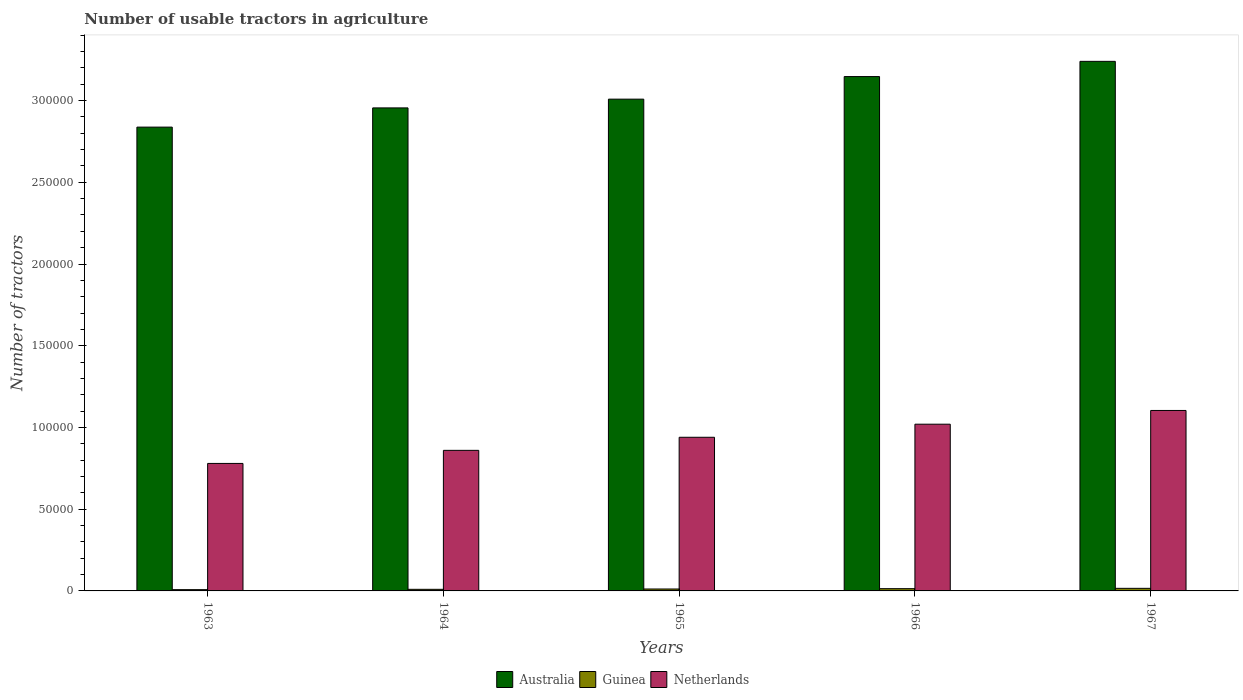How many different coloured bars are there?
Keep it short and to the point. 3. Are the number of bars per tick equal to the number of legend labels?
Make the answer very short. Yes. Are the number of bars on each tick of the X-axis equal?
Provide a short and direct response. Yes. How many bars are there on the 2nd tick from the right?
Give a very brief answer. 3. What is the label of the 3rd group of bars from the left?
Your answer should be very brief. 1965. What is the number of usable tractors in agriculture in Guinea in 1965?
Provide a succinct answer. 1180. Across all years, what is the maximum number of usable tractors in agriculture in Guinea?
Provide a short and direct response. 1579. Across all years, what is the minimum number of usable tractors in agriculture in Netherlands?
Your answer should be very brief. 7.80e+04. In which year was the number of usable tractors in agriculture in Australia maximum?
Your answer should be compact. 1967. In which year was the number of usable tractors in agriculture in Australia minimum?
Your answer should be very brief. 1963. What is the total number of usable tractors in agriculture in Guinea in the graph?
Offer a very short reply. 5898. What is the difference between the number of usable tractors in agriculture in Guinea in 1964 and that in 1967?
Your answer should be compact. -599. What is the difference between the number of usable tractors in agriculture in Australia in 1965 and the number of usable tractors in agriculture in Netherlands in 1963?
Offer a very short reply. 2.23e+05. What is the average number of usable tractors in agriculture in Guinea per year?
Ensure brevity in your answer.  1179.6. In the year 1965, what is the difference between the number of usable tractors in agriculture in Netherlands and number of usable tractors in agriculture in Australia?
Provide a succinct answer. -2.07e+05. In how many years, is the number of usable tractors in agriculture in Australia greater than 310000?
Ensure brevity in your answer.  2. What is the ratio of the number of usable tractors in agriculture in Guinea in 1964 to that in 1967?
Ensure brevity in your answer.  0.62. Is the difference between the number of usable tractors in agriculture in Netherlands in 1965 and 1967 greater than the difference between the number of usable tractors in agriculture in Australia in 1965 and 1967?
Make the answer very short. Yes. What is the difference between the highest and the second highest number of usable tractors in agriculture in Netherlands?
Your answer should be compact. 8400. What is the difference between the highest and the lowest number of usable tractors in agriculture in Australia?
Your answer should be very brief. 4.02e+04. Is the sum of the number of usable tractors in agriculture in Netherlands in 1966 and 1967 greater than the maximum number of usable tractors in agriculture in Guinea across all years?
Your answer should be very brief. Yes. What does the 2nd bar from the right in 1966 represents?
Your response must be concise. Guinea. Are all the bars in the graph horizontal?
Offer a terse response. No. How many years are there in the graph?
Ensure brevity in your answer.  5. What is the difference between two consecutive major ticks on the Y-axis?
Your answer should be very brief. 5.00e+04. Are the values on the major ticks of Y-axis written in scientific E-notation?
Keep it short and to the point. No. How many legend labels are there?
Keep it short and to the point. 3. How are the legend labels stacked?
Ensure brevity in your answer.  Horizontal. What is the title of the graph?
Your answer should be very brief. Number of usable tractors in agriculture. Does "Portugal" appear as one of the legend labels in the graph?
Make the answer very short. No. What is the label or title of the X-axis?
Keep it short and to the point. Years. What is the label or title of the Y-axis?
Your answer should be compact. Number of tractors. What is the Number of tractors in Australia in 1963?
Provide a short and direct response. 2.84e+05. What is the Number of tractors in Guinea in 1963?
Provide a short and direct response. 780. What is the Number of tractors in Netherlands in 1963?
Ensure brevity in your answer.  7.80e+04. What is the Number of tractors of Australia in 1964?
Your response must be concise. 2.96e+05. What is the Number of tractors of Guinea in 1964?
Your answer should be compact. 980. What is the Number of tractors of Netherlands in 1964?
Make the answer very short. 8.60e+04. What is the Number of tractors in Australia in 1965?
Keep it short and to the point. 3.01e+05. What is the Number of tractors of Guinea in 1965?
Offer a terse response. 1180. What is the Number of tractors of Netherlands in 1965?
Your answer should be compact. 9.40e+04. What is the Number of tractors in Australia in 1966?
Provide a succinct answer. 3.15e+05. What is the Number of tractors of Guinea in 1966?
Give a very brief answer. 1379. What is the Number of tractors in Netherlands in 1966?
Your answer should be compact. 1.02e+05. What is the Number of tractors in Australia in 1967?
Your answer should be compact. 3.24e+05. What is the Number of tractors of Guinea in 1967?
Give a very brief answer. 1579. What is the Number of tractors of Netherlands in 1967?
Offer a terse response. 1.10e+05. Across all years, what is the maximum Number of tractors in Australia?
Your answer should be compact. 3.24e+05. Across all years, what is the maximum Number of tractors in Guinea?
Provide a succinct answer. 1579. Across all years, what is the maximum Number of tractors of Netherlands?
Give a very brief answer. 1.10e+05. Across all years, what is the minimum Number of tractors of Australia?
Offer a terse response. 2.84e+05. Across all years, what is the minimum Number of tractors in Guinea?
Offer a terse response. 780. Across all years, what is the minimum Number of tractors of Netherlands?
Provide a succinct answer. 7.80e+04. What is the total Number of tractors in Australia in the graph?
Offer a terse response. 1.52e+06. What is the total Number of tractors in Guinea in the graph?
Give a very brief answer. 5898. What is the total Number of tractors in Netherlands in the graph?
Your answer should be compact. 4.70e+05. What is the difference between the Number of tractors in Australia in 1963 and that in 1964?
Keep it short and to the point. -1.18e+04. What is the difference between the Number of tractors of Guinea in 1963 and that in 1964?
Provide a short and direct response. -200. What is the difference between the Number of tractors of Netherlands in 1963 and that in 1964?
Provide a succinct answer. -8000. What is the difference between the Number of tractors of Australia in 1963 and that in 1965?
Make the answer very short. -1.71e+04. What is the difference between the Number of tractors of Guinea in 1963 and that in 1965?
Your answer should be compact. -400. What is the difference between the Number of tractors in Netherlands in 1963 and that in 1965?
Ensure brevity in your answer.  -1.60e+04. What is the difference between the Number of tractors of Australia in 1963 and that in 1966?
Offer a terse response. -3.09e+04. What is the difference between the Number of tractors of Guinea in 1963 and that in 1966?
Your response must be concise. -599. What is the difference between the Number of tractors in Netherlands in 1963 and that in 1966?
Offer a terse response. -2.40e+04. What is the difference between the Number of tractors in Australia in 1963 and that in 1967?
Provide a short and direct response. -4.02e+04. What is the difference between the Number of tractors in Guinea in 1963 and that in 1967?
Offer a terse response. -799. What is the difference between the Number of tractors of Netherlands in 1963 and that in 1967?
Provide a short and direct response. -3.24e+04. What is the difference between the Number of tractors in Australia in 1964 and that in 1965?
Make the answer very short. -5357. What is the difference between the Number of tractors of Guinea in 1964 and that in 1965?
Give a very brief answer. -200. What is the difference between the Number of tractors in Netherlands in 1964 and that in 1965?
Make the answer very short. -8000. What is the difference between the Number of tractors in Australia in 1964 and that in 1966?
Your answer should be very brief. -1.92e+04. What is the difference between the Number of tractors of Guinea in 1964 and that in 1966?
Ensure brevity in your answer.  -399. What is the difference between the Number of tractors in Netherlands in 1964 and that in 1966?
Offer a terse response. -1.60e+04. What is the difference between the Number of tractors of Australia in 1964 and that in 1967?
Offer a very short reply. -2.85e+04. What is the difference between the Number of tractors in Guinea in 1964 and that in 1967?
Provide a short and direct response. -599. What is the difference between the Number of tractors in Netherlands in 1964 and that in 1967?
Your answer should be very brief. -2.44e+04. What is the difference between the Number of tractors of Australia in 1965 and that in 1966?
Keep it short and to the point. -1.38e+04. What is the difference between the Number of tractors of Guinea in 1965 and that in 1966?
Offer a very short reply. -199. What is the difference between the Number of tractors in Netherlands in 1965 and that in 1966?
Make the answer very short. -8000. What is the difference between the Number of tractors in Australia in 1965 and that in 1967?
Provide a succinct answer. -2.31e+04. What is the difference between the Number of tractors of Guinea in 1965 and that in 1967?
Give a very brief answer. -399. What is the difference between the Number of tractors of Netherlands in 1965 and that in 1967?
Your answer should be compact. -1.64e+04. What is the difference between the Number of tractors in Australia in 1966 and that in 1967?
Your response must be concise. -9312. What is the difference between the Number of tractors of Guinea in 1966 and that in 1967?
Ensure brevity in your answer.  -200. What is the difference between the Number of tractors of Netherlands in 1966 and that in 1967?
Your answer should be compact. -8400. What is the difference between the Number of tractors of Australia in 1963 and the Number of tractors of Guinea in 1964?
Your response must be concise. 2.83e+05. What is the difference between the Number of tractors in Australia in 1963 and the Number of tractors in Netherlands in 1964?
Keep it short and to the point. 1.98e+05. What is the difference between the Number of tractors of Guinea in 1963 and the Number of tractors of Netherlands in 1964?
Provide a short and direct response. -8.52e+04. What is the difference between the Number of tractors in Australia in 1963 and the Number of tractors in Guinea in 1965?
Offer a terse response. 2.83e+05. What is the difference between the Number of tractors in Australia in 1963 and the Number of tractors in Netherlands in 1965?
Your answer should be very brief. 1.90e+05. What is the difference between the Number of tractors of Guinea in 1963 and the Number of tractors of Netherlands in 1965?
Offer a very short reply. -9.32e+04. What is the difference between the Number of tractors in Australia in 1963 and the Number of tractors in Guinea in 1966?
Your answer should be very brief. 2.82e+05. What is the difference between the Number of tractors of Australia in 1963 and the Number of tractors of Netherlands in 1966?
Make the answer very short. 1.82e+05. What is the difference between the Number of tractors in Guinea in 1963 and the Number of tractors in Netherlands in 1966?
Ensure brevity in your answer.  -1.01e+05. What is the difference between the Number of tractors of Australia in 1963 and the Number of tractors of Guinea in 1967?
Provide a short and direct response. 2.82e+05. What is the difference between the Number of tractors in Australia in 1963 and the Number of tractors in Netherlands in 1967?
Ensure brevity in your answer.  1.73e+05. What is the difference between the Number of tractors of Guinea in 1963 and the Number of tractors of Netherlands in 1967?
Offer a terse response. -1.10e+05. What is the difference between the Number of tractors in Australia in 1964 and the Number of tractors in Guinea in 1965?
Make the answer very short. 2.94e+05. What is the difference between the Number of tractors of Australia in 1964 and the Number of tractors of Netherlands in 1965?
Your answer should be compact. 2.02e+05. What is the difference between the Number of tractors in Guinea in 1964 and the Number of tractors in Netherlands in 1965?
Keep it short and to the point. -9.30e+04. What is the difference between the Number of tractors in Australia in 1964 and the Number of tractors in Guinea in 1966?
Provide a succinct answer. 2.94e+05. What is the difference between the Number of tractors of Australia in 1964 and the Number of tractors of Netherlands in 1966?
Offer a very short reply. 1.94e+05. What is the difference between the Number of tractors of Guinea in 1964 and the Number of tractors of Netherlands in 1966?
Your answer should be compact. -1.01e+05. What is the difference between the Number of tractors of Australia in 1964 and the Number of tractors of Guinea in 1967?
Provide a succinct answer. 2.94e+05. What is the difference between the Number of tractors in Australia in 1964 and the Number of tractors in Netherlands in 1967?
Keep it short and to the point. 1.85e+05. What is the difference between the Number of tractors in Guinea in 1964 and the Number of tractors in Netherlands in 1967?
Your answer should be compact. -1.09e+05. What is the difference between the Number of tractors of Australia in 1965 and the Number of tractors of Guinea in 1966?
Your answer should be compact. 2.99e+05. What is the difference between the Number of tractors in Australia in 1965 and the Number of tractors in Netherlands in 1966?
Offer a terse response. 1.99e+05. What is the difference between the Number of tractors in Guinea in 1965 and the Number of tractors in Netherlands in 1966?
Your response must be concise. -1.01e+05. What is the difference between the Number of tractors in Australia in 1965 and the Number of tractors in Guinea in 1967?
Give a very brief answer. 2.99e+05. What is the difference between the Number of tractors in Australia in 1965 and the Number of tractors in Netherlands in 1967?
Provide a short and direct response. 1.90e+05. What is the difference between the Number of tractors of Guinea in 1965 and the Number of tractors of Netherlands in 1967?
Provide a short and direct response. -1.09e+05. What is the difference between the Number of tractors in Australia in 1966 and the Number of tractors in Guinea in 1967?
Make the answer very short. 3.13e+05. What is the difference between the Number of tractors of Australia in 1966 and the Number of tractors of Netherlands in 1967?
Your answer should be compact. 2.04e+05. What is the difference between the Number of tractors in Guinea in 1966 and the Number of tractors in Netherlands in 1967?
Give a very brief answer. -1.09e+05. What is the average Number of tractors in Australia per year?
Your response must be concise. 3.04e+05. What is the average Number of tractors in Guinea per year?
Your response must be concise. 1179.6. What is the average Number of tractors of Netherlands per year?
Offer a terse response. 9.41e+04. In the year 1963, what is the difference between the Number of tractors in Australia and Number of tractors in Guinea?
Give a very brief answer. 2.83e+05. In the year 1963, what is the difference between the Number of tractors of Australia and Number of tractors of Netherlands?
Your response must be concise. 2.06e+05. In the year 1963, what is the difference between the Number of tractors of Guinea and Number of tractors of Netherlands?
Provide a short and direct response. -7.72e+04. In the year 1964, what is the difference between the Number of tractors of Australia and Number of tractors of Guinea?
Your response must be concise. 2.95e+05. In the year 1964, what is the difference between the Number of tractors of Australia and Number of tractors of Netherlands?
Offer a very short reply. 2.10e+05. In the year 1964, what is the difference between the Number of tractors of Guinea and Number of tractors of Netherlands?
Your response must be concise. -8.50e+04. In the year 1965, what is the difference between the Number of tractors in Australia and Number of tractors in Guinea?
Offer a very short reply. 3.00e+05. In the year 1965, what is the difference between the Number of tractors of Australia and Number of tractors of Netherlands?
Your answer should be compact. 2.07e+05. In the year 1965, what is the difference between the Number of tractors of Guinea and Number of tractors of Netherlands?
Provide a succinct answer. -9.28e+04. In the year 1966, what is the difference between the Number of tractors in Australia and Number of tractors in Guinea?
Your answer should be compact. 3.13e+05. In the year 1966, what is the difference between the Number of tractors of Australia and Number of tractors of Netherlands?
Keep it short and to the point. 2.13e+05. In the year 1966, what is the difference between the Number of tractors of Guinea and Number of tractors of Netherlands?
Your answer should be very brief. -1.01e+05. In the year 1967, what is the difference between the Number of tractors in Australia and Number of tractors in Guinea?
Provide a short and direct response. 3.22e+05. In the year 1967, what is the difference between the Number of tractors of Australia and Number of tractors of Netherlands?
Provide a succinct answer. 2.14e+05. In the year 1967, what is the difference between the Number of tractors of Guinea and Number of tractors of Netherlands?
Offer a terse response. -1.09e+05. What is the ratio of the Number of tractors in Australia in 1963 to that in 1964?
Offer a very short reply. 0.96. What is the ratio of the Number of tractors in Guinea in 1963 to that in 1964?
Provide a short and direct response. 0.8. What is the ratio of the Number of tractors of Netherlands in 1963 to that in 1964?
Make the answer very short. 0.91. What is the ratio of the Number of tractors of Australia in 1963 to that in 1965?
Offer a terse response. 0.94. What is the ratio of the Number of tractors of Guinea in 1963 to that in 1965?
Give a very brief answer. 0.66. What is the ratio of the Number of tractors in Netherlands in 1963 to that in 1965?
Keep it short and to the point. 0.83. What is the ratio of the Number of tractors of Australia in 1963 to that in 1966?
Offer a terse response. 0.9. What is the ratio of the Number of tractors of Guinea in 1963 to that in 1966?
Your response must be concise. 0.57. What is the ratio of the Number of tractors in Netherlands in 1963 to that in 1966?
Offer a terse response. 0.76. What is the ratio of the Number of tractors of Australia in 1963 to that in 1967?
Your answer should be very brief. 0.88. What is the ratio of the Number of tractors of Guinea in 1963 to that in 1967?
Provide a succinct answer. 0.49. What is the ratio of the Number of tractors of Netherlands in 1963 to that in 1967?
Keep it short and to the point. 0.71. What is the ratio of the Number of tractors in Australia in 1964 to that in 1965?
Provide a short and direct response. 0.98. What is the ratio of the Number of tractors of Guinea in 1964 to that in 1965?
Offer a very short reply. 0.83. What is the ratio of the Number of tractors in Netherlands in 1964 to that in 1965?
Offer a very short reply. 0.91. What is the ratio of the Number of tractors of Australia in 1964 to that in 1966?
Your answer should be compact. 0.94. What is the ratio of the Number of tractors of Guinea in 1964 to that in 1966?
Give a very brief answer. 0.71. What is the ratio of the Number of tractors of Netherlands in 1964 to that in 1966?
Provide a short and direct response. 0.84. What is the ratio of the Number of tractors of Australia in 1964 to that in 1967?
Your answer should be compact. 0.91. What is the ratio of the Number of tractors in Guinea in 1964 to that in 1967?
Provide a succinct answer. 0.62. What is the ratio of the Number of tractors of Netherlands in 1964 to that in 1967?
Provide a succinct answer. 0.78. What is the ratio of the Number of tractors in Australia in 1965 to that in 1966?
Make the answer very short. 0.96. What is the ratio of the Number of tractors of Guinea in 1965 to that in 1966?
Your answer should be very brief. 0.86. What is the ratio of the Number of tractors in Netherlands in 1965 to that in 1966?
Make the answer very short. 0.92. What is the ratio of the Number of tractors in Australia in 1965 to that in 1967?
Provide a short and direct response. 0.93. What is the ratio of the Number of tractors in Guinea in 1965 to that in 1967?
Provide a succinct answer. 0.75. What is the ratio of the Number of tractors of Netherlands in 1965 to that in 1967?
Offer a very short reply. 0.85. What is the ratio of the Number of tractors in Australia in 1966 to that in 1967?
Offer a terse response. 0.97. What is the ratio of the Number of tractors of Guinea in 1966 to that in 1967?
Offer a very short reply. 0.87. What is the ratio of the Number of tractors in Netherlands in 1966 to that in 1967?
Give a very brief answer. 0.92. What is the difference between the highest and the second highest Number of tractors in Australia?
Provide a succinct answer. 9312. What is the difference between the highest and the second highest Number of tractors in Netherlands?
Your answer should be very brief. 8400. What is the difference between the highest and the lowest Number of tractors of Australia?
Give a very brief answer. 4.02e+04. What is the difference between the highest and the lowest Number of tractors in Guinea?
Keep it short and to the point. 799. What is the difference between the highest and the lowest Number of tractors in Netherlands?
Give a very brief answer. 3.24e+04. 